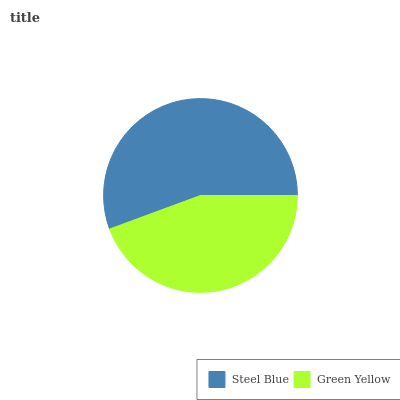Is Green Yellow the minimum?
Answer yes or no. Yes. Is Steel Blue the maximum?
Answer yes or no. Yes. Is Green Yellow the maximum?
Answer yes or no. No. Is Steel Blue greater than Green Yellow?
Answer yes or no. Yes. Is Green Yellow less than Steel Blue?
Answer yes or no. Yes. Is Green Yellow greater than Steel Blue?
Answer yes or no. No. Is Steel Blue less than Green Yellow?
Answer yes or no. No. Is Steel Blue the high median?
Answer yes or no. Yes. Is Green Yellow the low median?
Answer yes or no. Yes. Is Green Yellow the high median?
Answer yes or no. No. Is Steel Blue the low median?
Answer yes or no. No. 